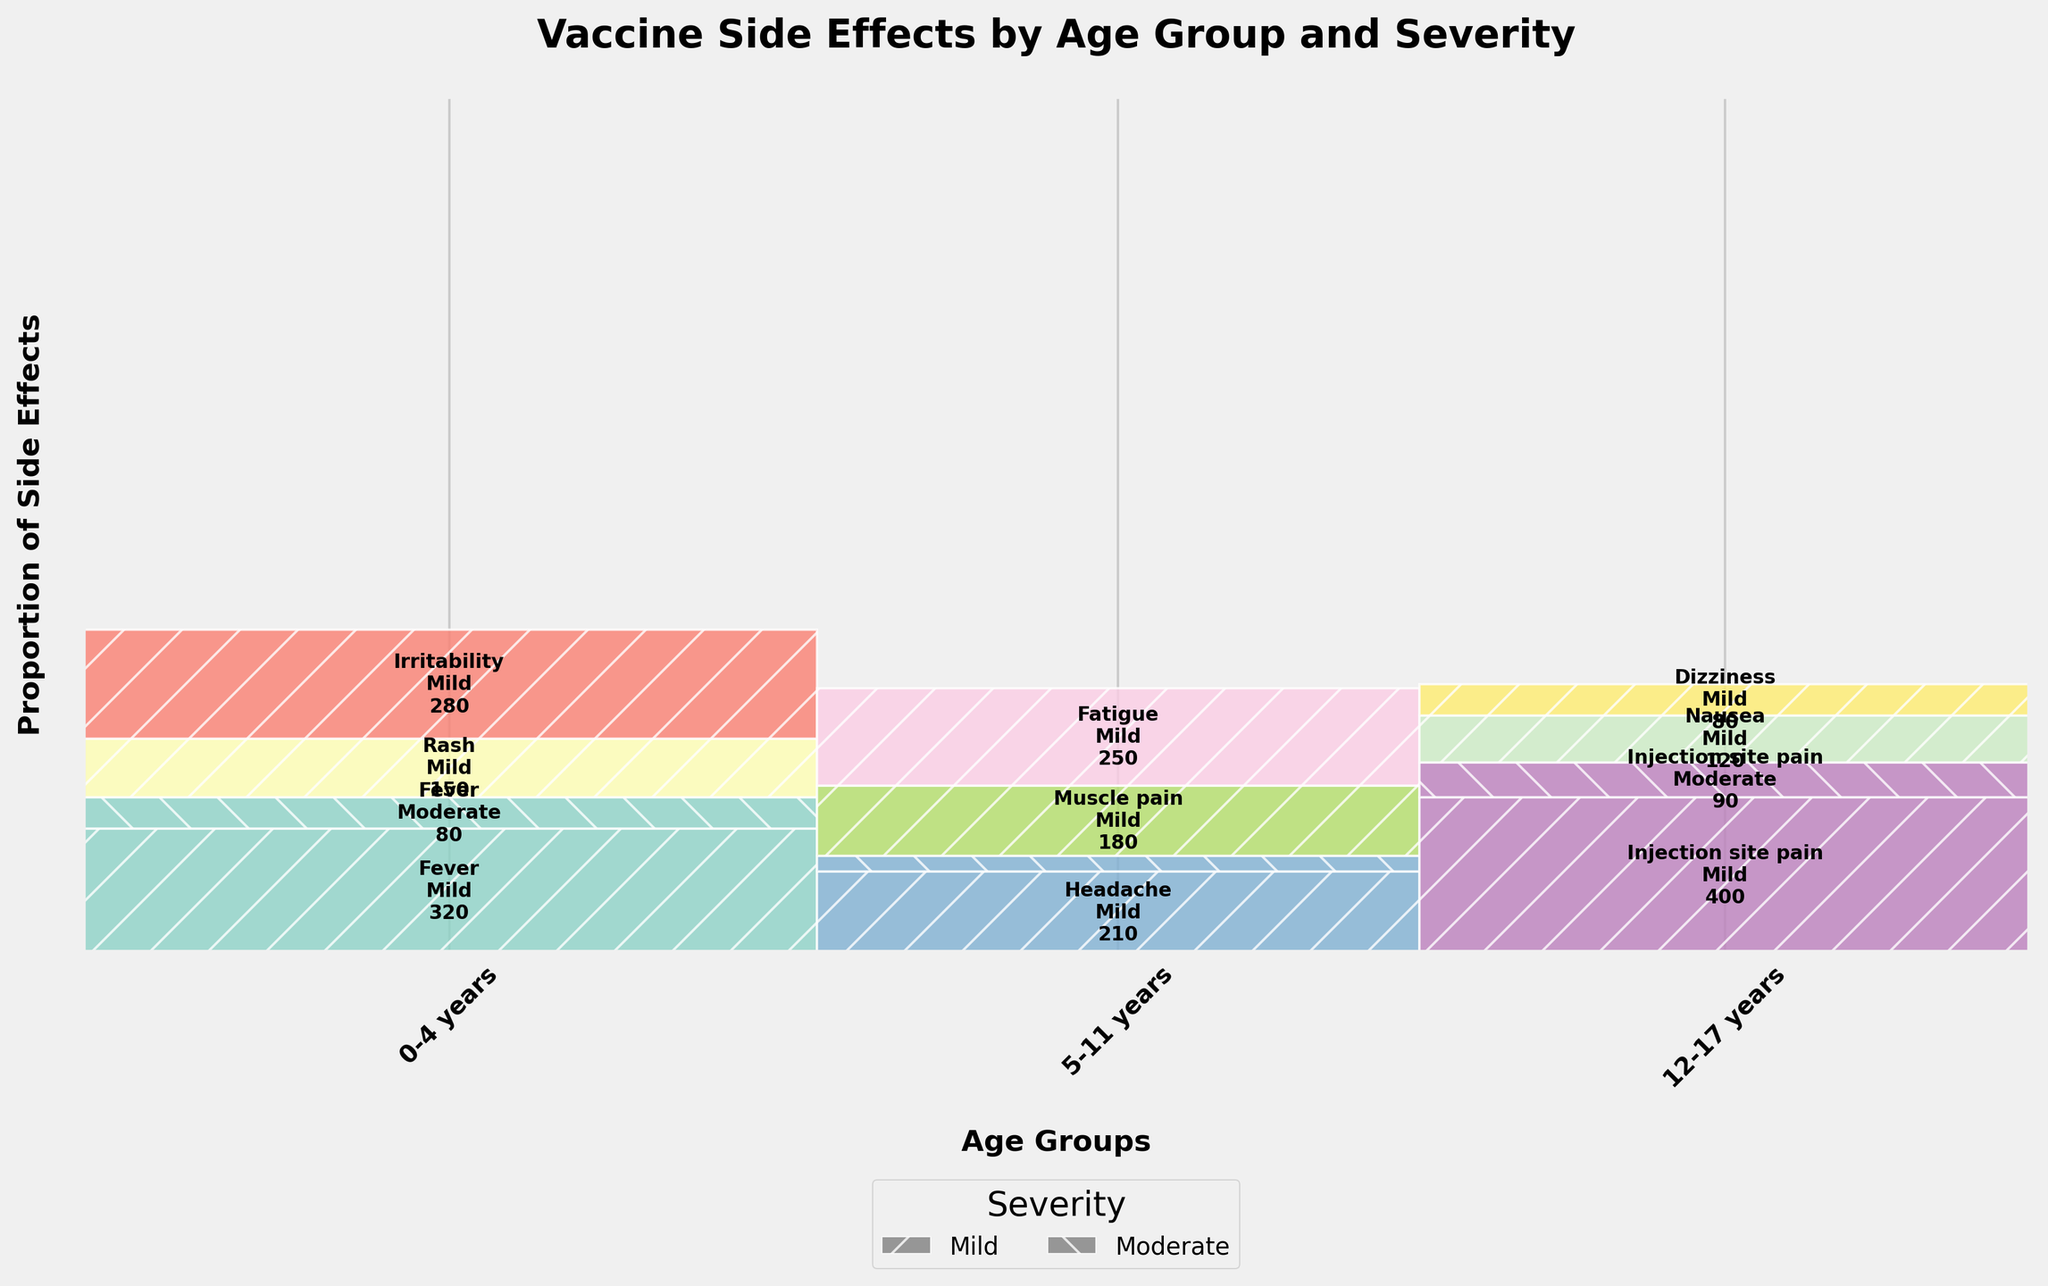Which age group reported the highest number of mild side effects? Looking at the proportions, the 12-17 years group has a large section with Injection site pain (Mild), indicating they reported the highest number of mild side effects.
Answer: 12-17 years How many moderate side effects were reported for the 0-4 years age group? Adding up the counts for moderate side effects within the 0-4 years group: Fever (80) + Rash (0)+ Irritability (0). The total is 80.
Answer: 80 Which age group reported side effects related to fatigue? The age group which has a section labeled "Fatigue" is 5-11 years.
Answer: 5-11 years Which severity of injection site pain is more common in the 12-17 years age group? Comparing the heights of the rectangles labeled Injection site pain in the 12-17 years group, the Mild side effect has a larger section compared to Moderate, indicating it is more common.
Answer: Mild Among mild side effects reported by the 5-11 years group, which is the least common? For the 5-11 years group, the sections for Mild side effects are Headache, Muscle pain, and Fatigue. Headache has the smallest rectangle, suggesting it is the least common mild side effect.
Answer: Headache How many different side effects are reported by the 0-4 years group? Counting the unique labels in the 0-4 years section, we see Fever, Rash, and Irritability, which means there are three different side effects.
Answer: 3 Compare the number of mild side effects to moderate side effects in the 12-17 years group. Which is greater? Summing the counts of mild side effects (Injection site pain, Nausea, Dizziness) and moderate side effects (Injection site pain) in the 12-17 years group, we see Mild: 400 + 120 + 80 = 600 and Moderate: 90. Mild is greater.
Answer: Mild What proportion of side effects in the 5-11 years group are related to headache? The total side effects in the 5-11 years group are Headache mild 210 + moderate 40 + Muscle pain 180 + Fatigue 250 = 680. Headache proportion: (210 + 40) / 680 = 250 / 680 ≈ 0.37.
Answer: approximately 37% Which side effect is represented with the most vibrant color? The question implies subjective judgment, but Injection site pain and Nausea use vibrant colors, concentrated in the 12-17 years group.
Answer: Injection site pain 